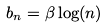<formula> <loc_0><loc_0><loc_500><loc_500>b _ { n } = \beta \log ( n )</formula> 